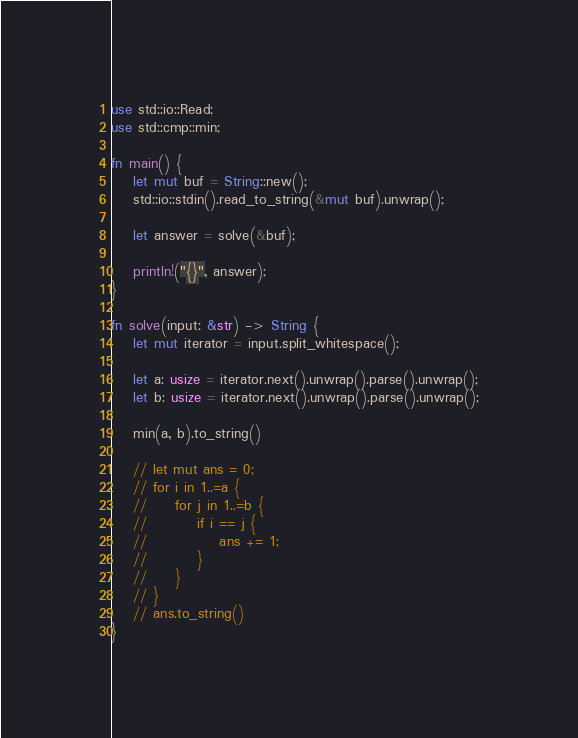Convert code to text. <code><loc_0><loc_0><loc_500><loc_500><_Rust_>use std::io::Read;
use std::cmp::min;

fn main() {
    let mut buf = String::new();
    std::io::stdin().read_to_string(&mut buf).unwrap();

    let answer = solve(&buf);

    println!("{}", answer);
}

fn solve(input: &str) -> String {
    let mut iterator = input.split_whitespace();

    let a: usize = iterator.next().unwrap().parse().unwrap();
    let b: usize = iterator.next().unwrap().parse().unwrap();

    min(a, b).to_string()

    // let mut ans = 0;
    // for i in 1..=a {
    //     for j in 1..=b {
    //         if i == j {
    //             ans += 1;
    //         }
    //     }
    // }
    // ans.to_string()
}
</code> 